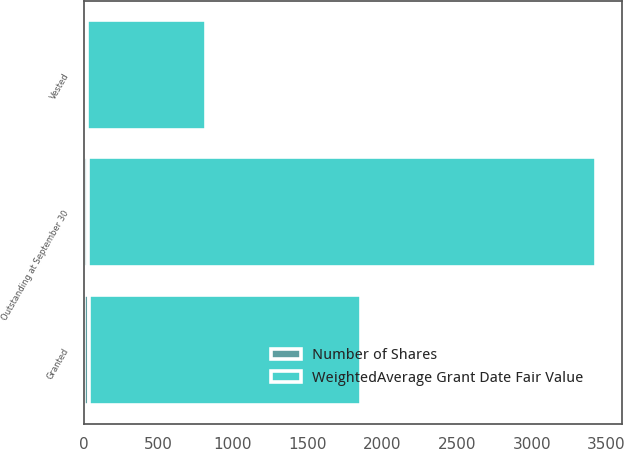Convert chart. <chart><loc_0><loc_0><loc_500><loc_500><stacked_bar_chart><ecel><fcel>Outstanding at September 30<fcel>Granted<fcel>Vested<nl><fcel>WeightedAverage Grant Date Fair Value<fcel>3398<fcel>1820<fcel>792<nl><fcel>Number of Shares<fcel>32.2<fcel>38.44<fcel>25.34<nl></chart> 